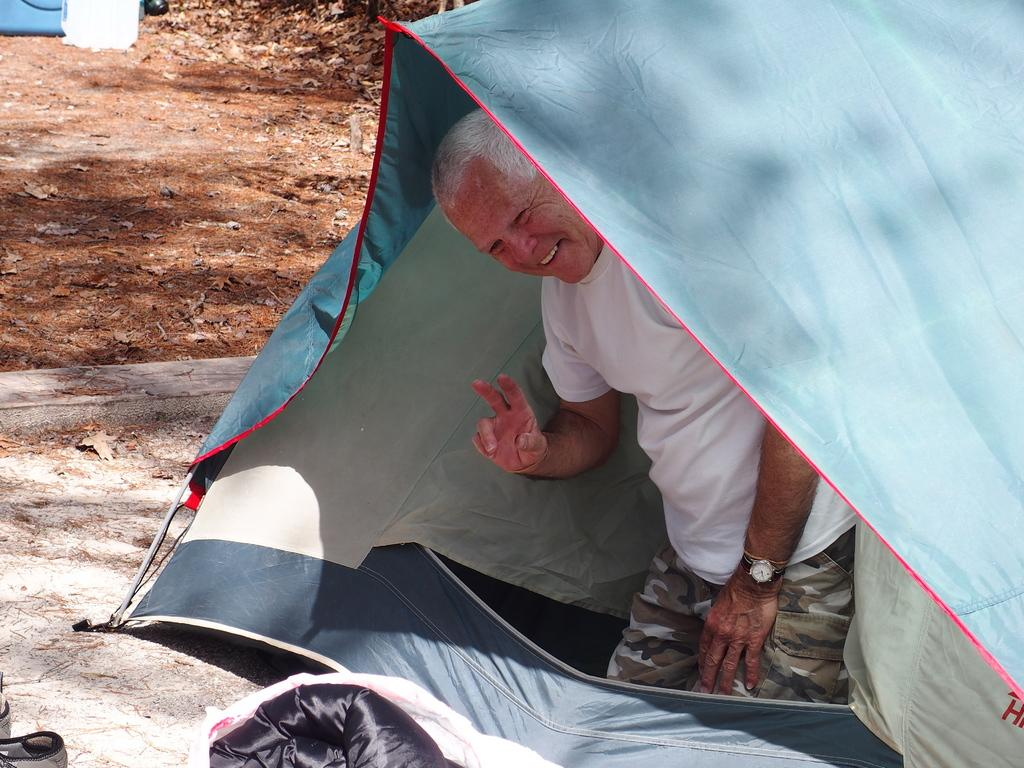What is the location of the old man in the image? The old man is inside a tent in the image. What is the old man wearing? The old man is wearing a white t-shirt in the image. What is the facial expression of the old man? The old man is smiling in the image. What can be seen on the ground in the background of the image? There are dried leaves on the ground in the background of the image. What type of shoes is the old man wearing in the image? The image does not show the old man's shoes, so we cannot determine what type of shoes he is wearing. 